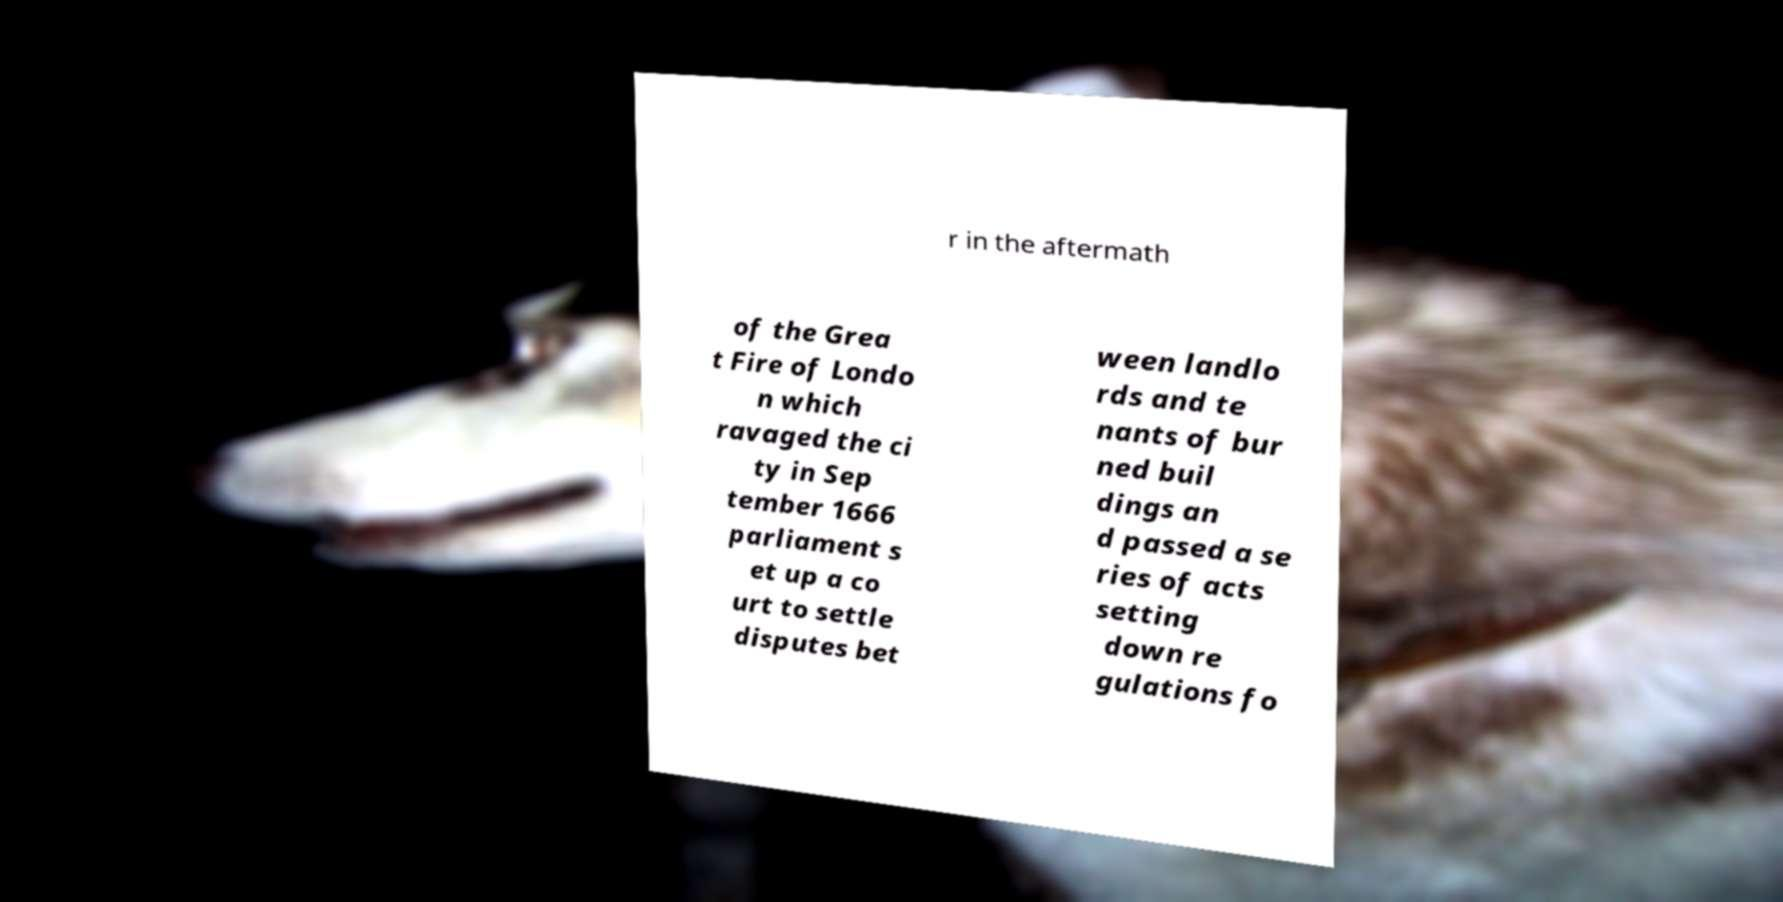Please read and relay the text visible in this image. What does it say? r in the aftermath of the Grea t Fire of Londo n which ravaged the ci ty in Sep tember 1666 parliament s et up a co urt to settle disputes bet ween landlo rds and te nants of bur ned buil dings an d passed a se ries of acts setting down re gulations fo 